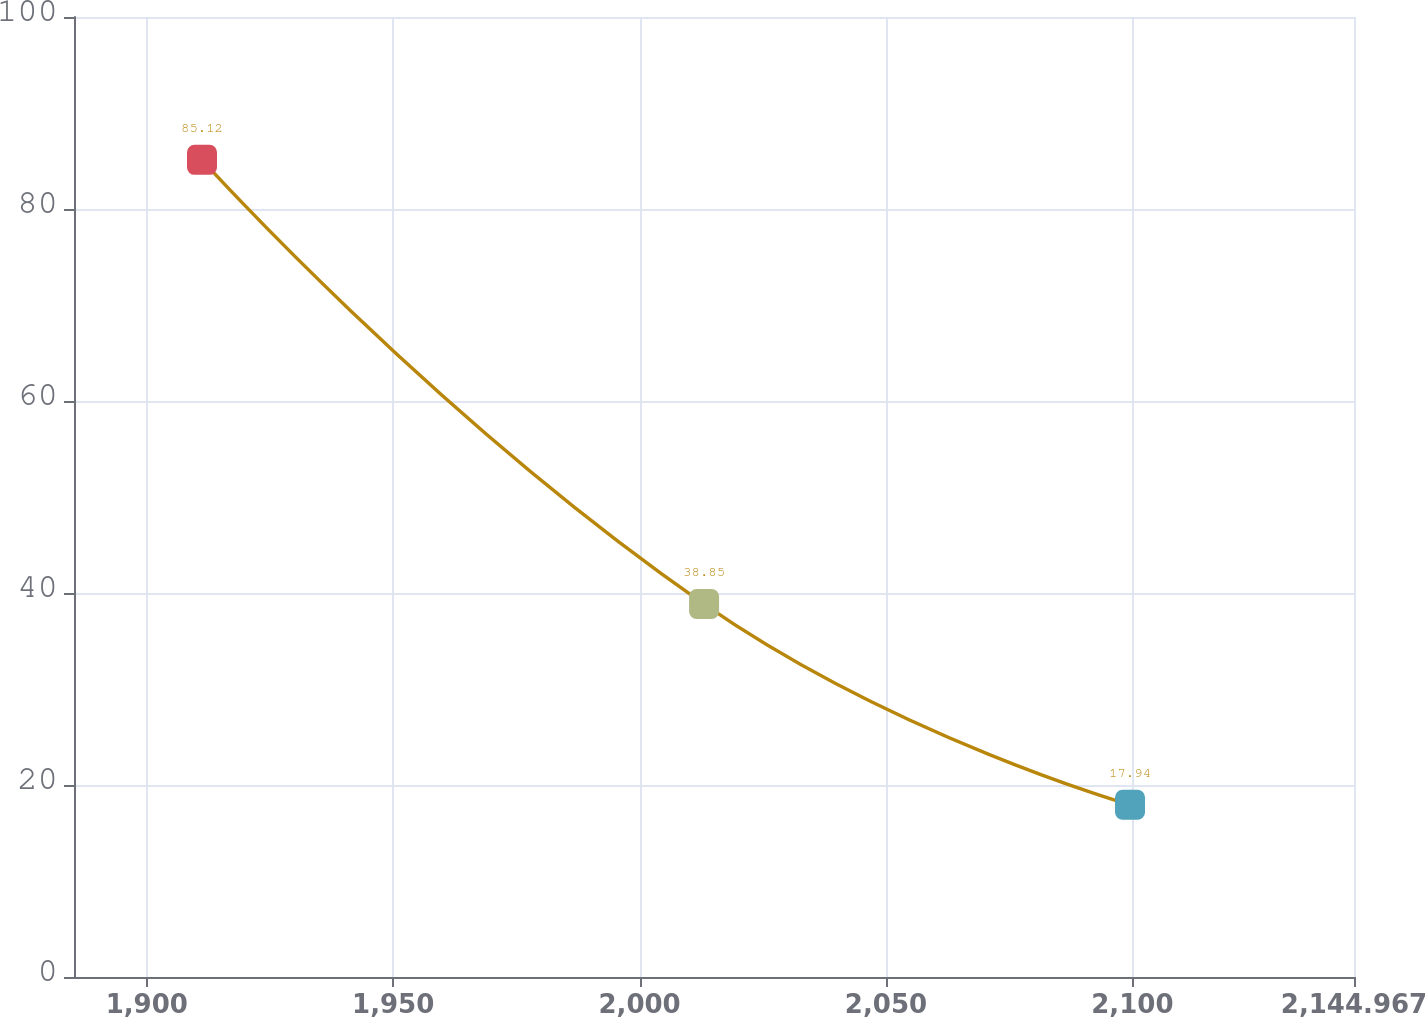<chart> <loc_0><loc_0><loc_500><loc_500><line_chart><ecel><fcel>$ 872.0<nl><fcel>1911.21<fcel>85.12<nl><fcel>2013.09<fcel>38.85<nl><fcel>2099.52<fcel>17.94<nl><fcel>2170.94<fcel>28.36<nl></chart> 